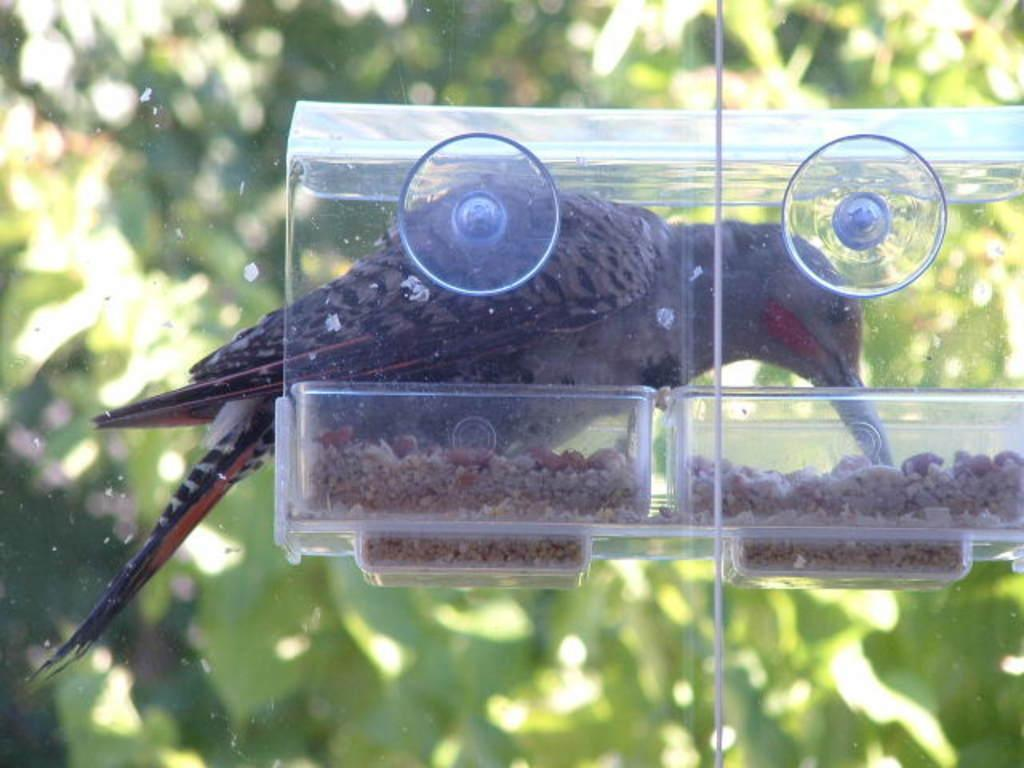What type of animal can be seen in the image? There is a bird in the image. What might the bird be interacting with in the image? The bird is interacting with a bird feeder in the image. What can be seen in the background of the image? Leaves are visible in the background of the image. What type of bread is the police officer eating in the image? There is no police officer or bread present in the image. 